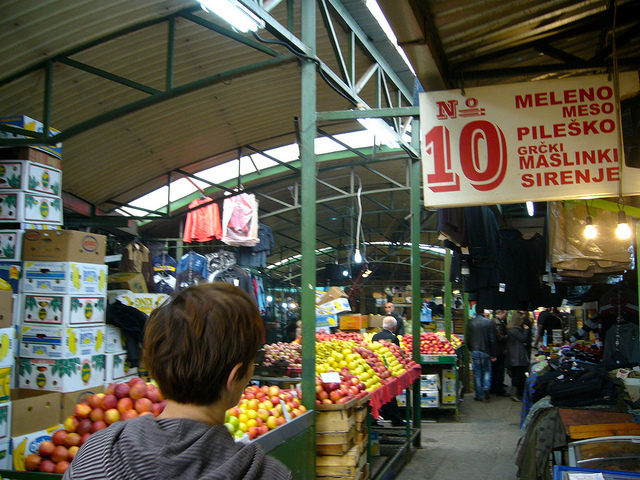Read all the text in this image. MELENO PILESKO MASLINK SIRENJE MESO O N 10 GRCKI 